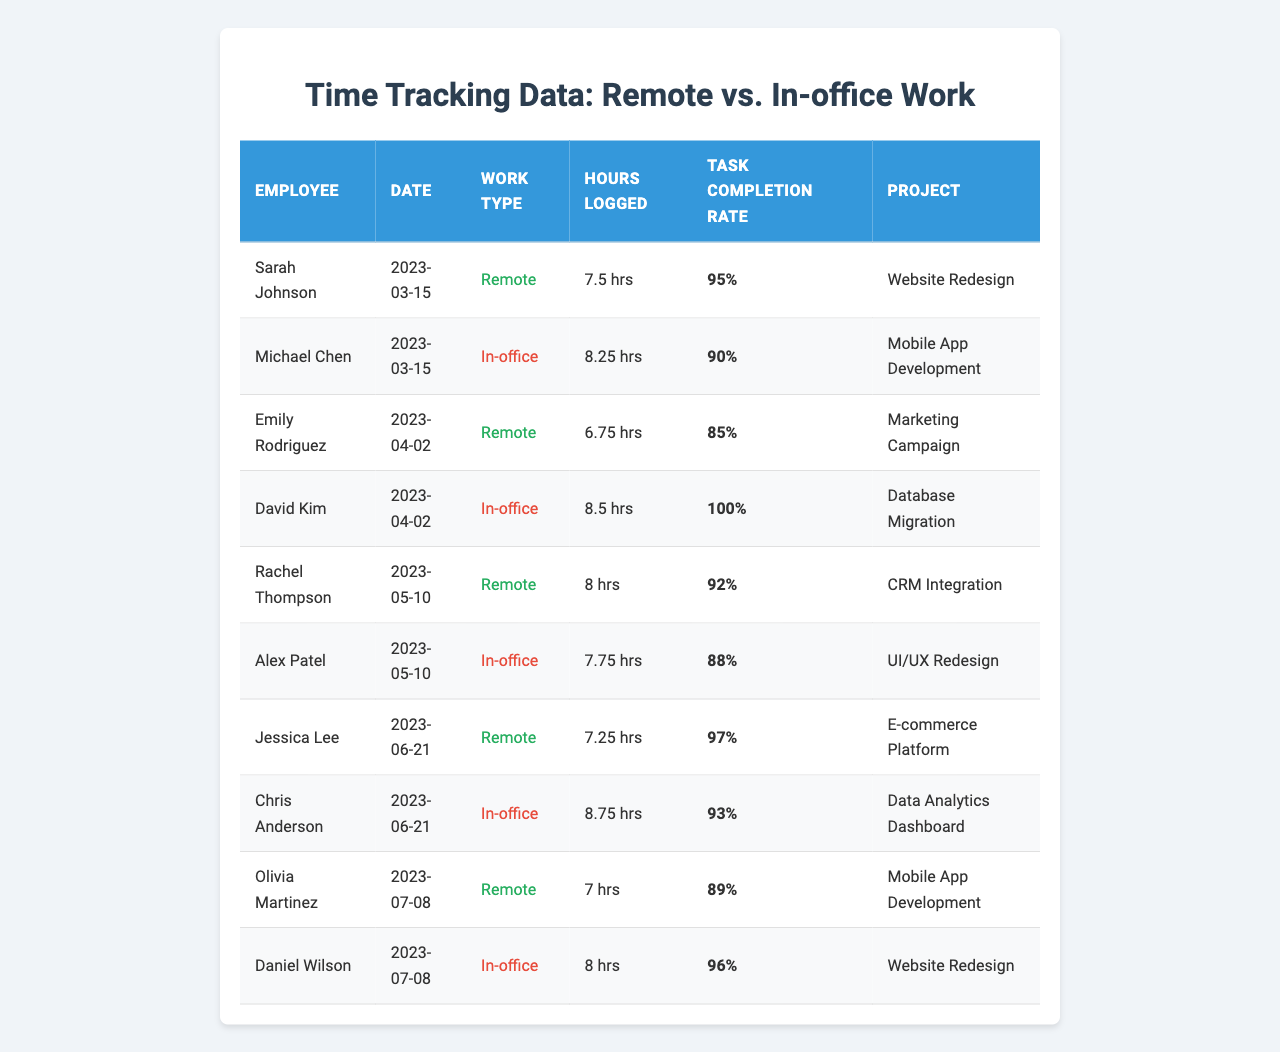What was the highest number of hours logged on a single day? Reviewing the table, David Kim logged the most hours at 8.5 on 2023-04-02.
Answer: 8.5 Which employee had the highest task completion rate? The highest task completion rate is 100%, achieved by David Kim on 2023-04-02.
Answer: 100% What is the average hours logged for remote workdays? The total hours logged for remote workdays are 7.5 + 6.75 + 8 + 7.25 + 7 = 36.5 hours. There are 5 remote workdays, so the average is 36.5 / 5 = 7.3 hours.
Answer: 7.3 Did Sarah Johnson work in the office on March 15? Sarah Johnson worked remotely on March 15, as noted in the table.
Answer: No How many projects were worked on by employees on remote days? The projects related to remote work are "Website Redesign", "Marketing Campaign", "CRM Integration", "E-commerce Platform", and "Mobile App Development". That totals to 5 unique projects.
Answer: 5 What is the difference between the total hours logged for in-office and remote work? Total hours for in-office work: 8.25 + 8.5 + 7.75 + 8.75 + 8 = 41.25 hours. Total for remote work: 7.5 + 6.75 + 8 + 7.25 + 7 = 36.5 hours. The difference is 41.25 - 36.5 = 4.75 hours.
Answer: 4.75 Was Alex Patel's task completion rate higher than Jessica Lee's? Alex Patel's task completion rate is 88%, while Jessica Lee's is 97%. Thus, Alex Patel's rate is lower.
Answer: No What is the median hours logged for in-office workdays? The hours logged for in-office work are 8.25, 8.5, 7.75, 8.75, 8. To find the median, we first order them: 7.75, 8.25, 8.5, 8, 8.75. The median value (middle value) is 8.5 hours.
Answer: 8.5 Which employee had the lowest task completion rate on a remote workday? The lowest task completion rate for remote work is 85%, recorded by Emily Rodriguez on April 2, 2023.
Answer: 85% How many remote workdays had an hours logged total greater than 7 hours? The remote workdays with more than 7 hours are on March 15 (7.5), May 10 (8), and June 21 (7.25). That's a total of 3 days.
Answer: 3 What was the task completion rate for the employee who worked closest to 8 hours on a remote workday? Rachel Thompson logged exactly 8 hours on May 10 with a task completion rate of 92%.
Answer: 92% 